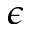<formula> <loc_0><loc_0><loc_500><loc_500>\epsilon</formula> 